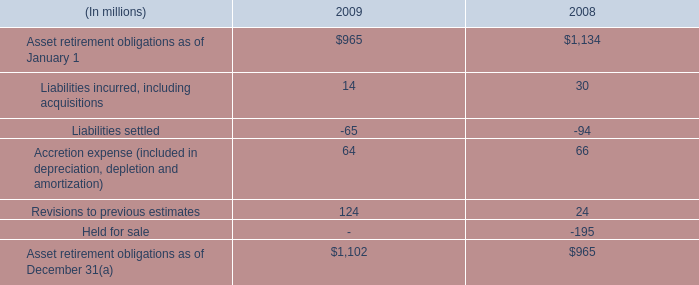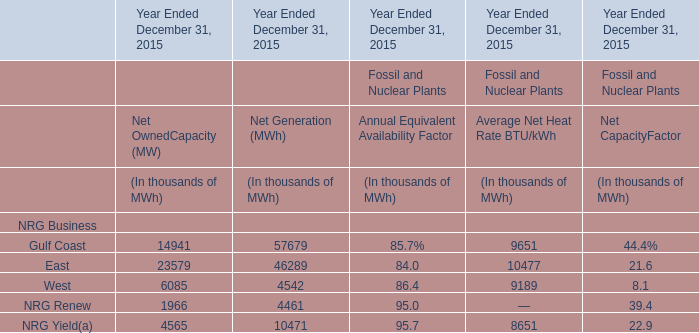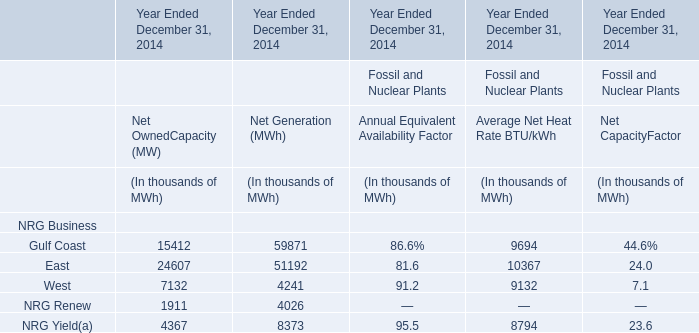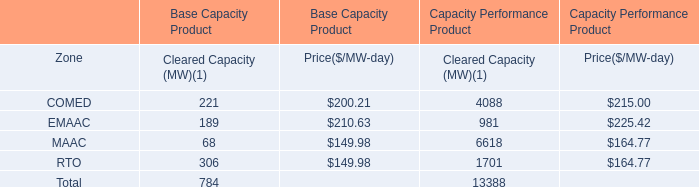What do all Net Generation (MWh) sum up in 2014 , excluding Gulf Coast and East? (in thousand) 
Computations: ((4241 + 4026) + 8373)
Answer: 16640.0. 